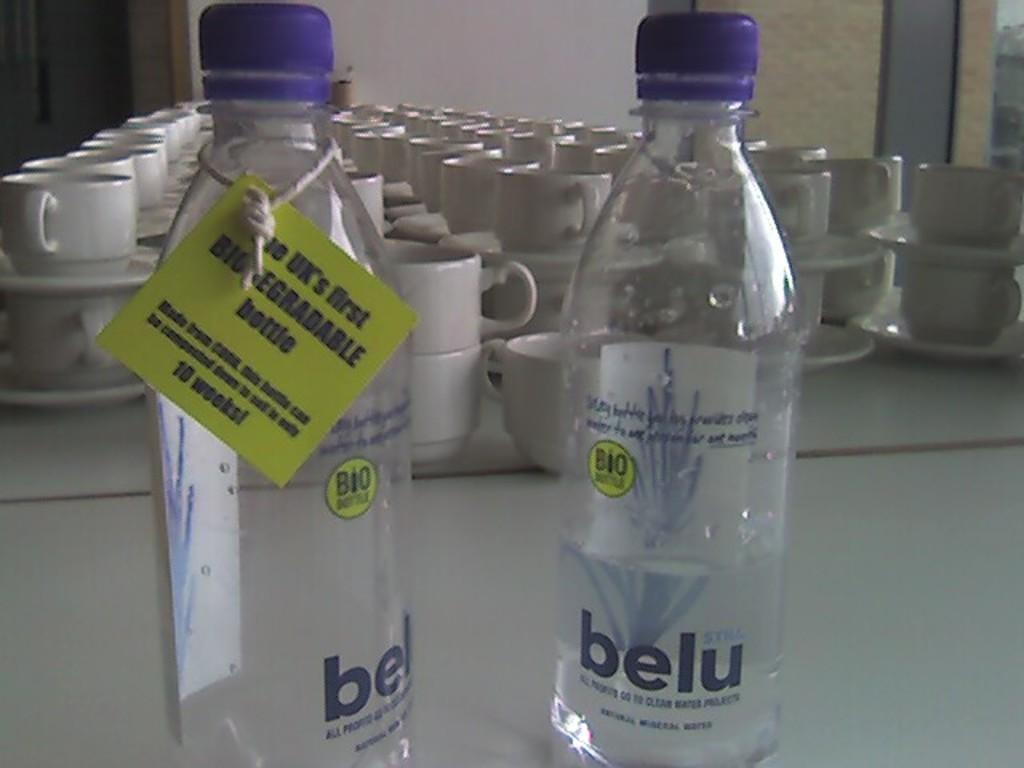<image>
Share a concise interpretation of the image provided. Two bottles of belu sit on a table in front of cups and saucers. 